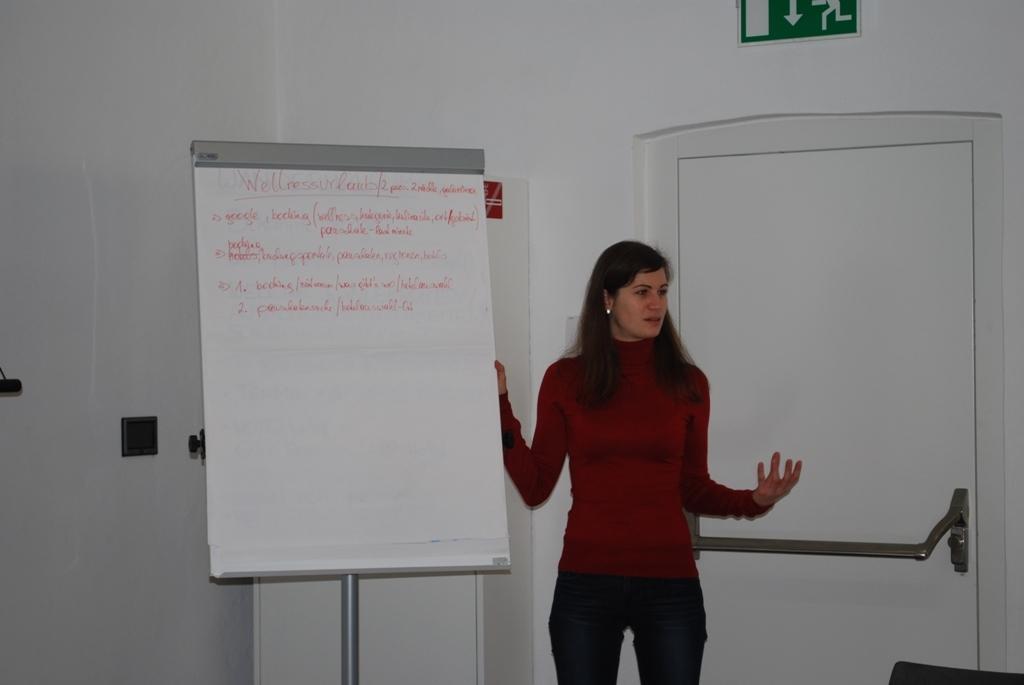Describe this image in one or two sentences. In this image I can see a woman and a white colour board in the front. I can also see something is written on the board and I can see she is wearing red and black colour dress. On the right side of this image I can see a white colour door and on it I can see an iron handle. On the top right side of this image I can see a green colour sign board. 